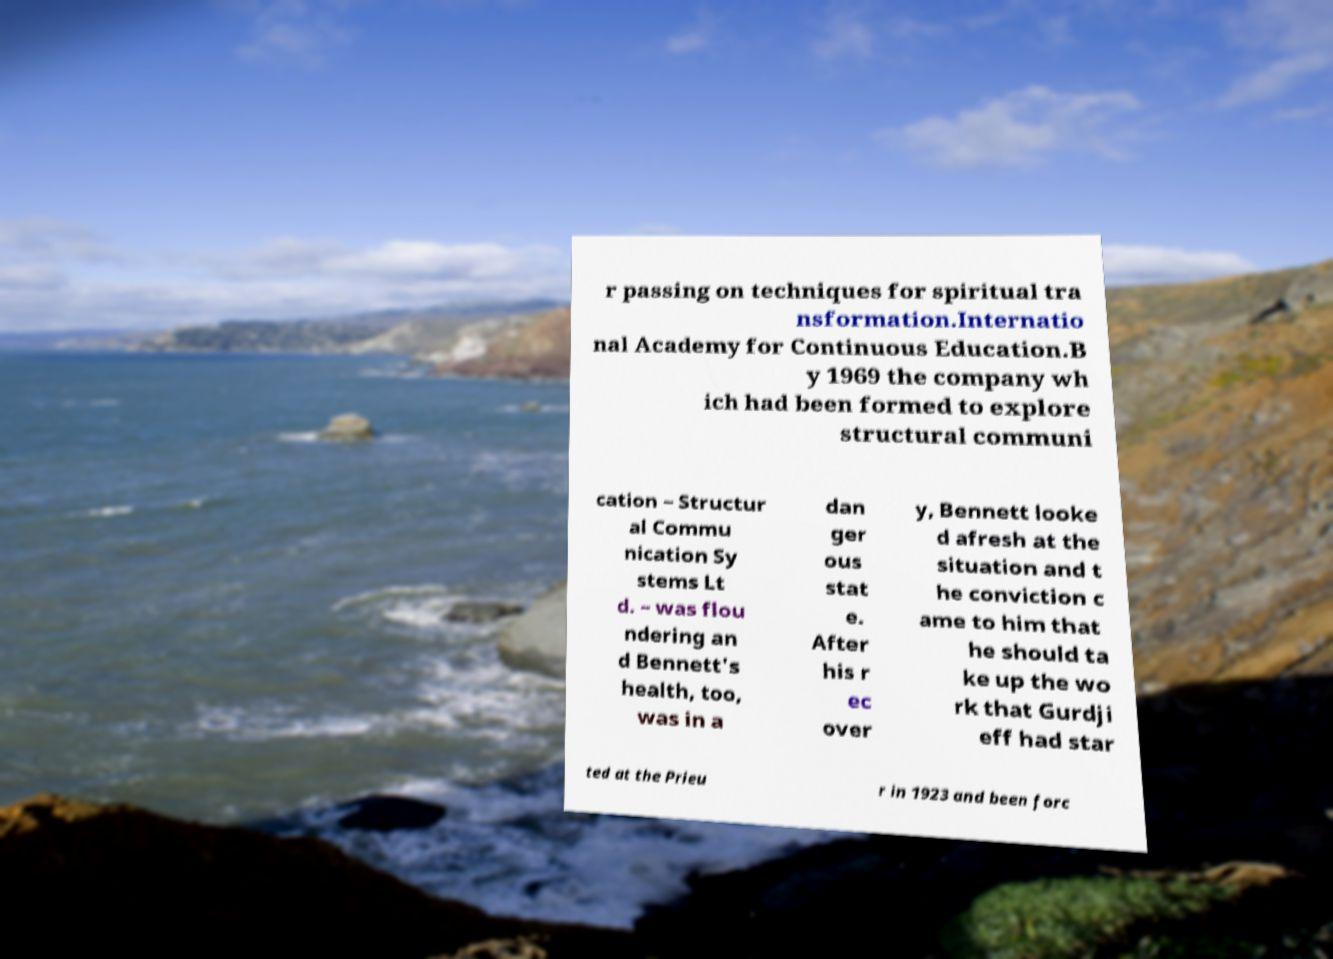Please read and relay the text visible in this image. What does it say? r passing on techniques for spiritual tra nsformation.Internatio nal Academy for Continuous Education.B y 1969 the company wh ich had been formed to explore structural communi cation – Structur al Commu nication Sy stems Lt d. – was flou ndering an d Bennett's health, too, was in a dan ger ous stat e. After his r ec over y, Bennett looke d afresh at the situation and t he conviction c ame to him that he should ta ke up the wo rk that Gurdji eff had star ted at the Prieu r in 1923 and been forc 